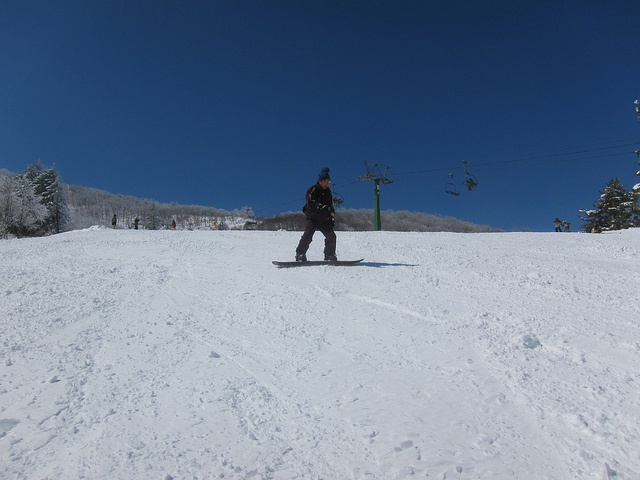Describe the objects in this image and their specific colors. I can see people in darkblue, black, gray, and navy tones, snowboard in darkblue, gray, and black tones, bench in navy, black, and darkblue tones, bench in black, darkblue, and navy tones, and people in darkblue, black, navy, gray, and blue tones in this image. 